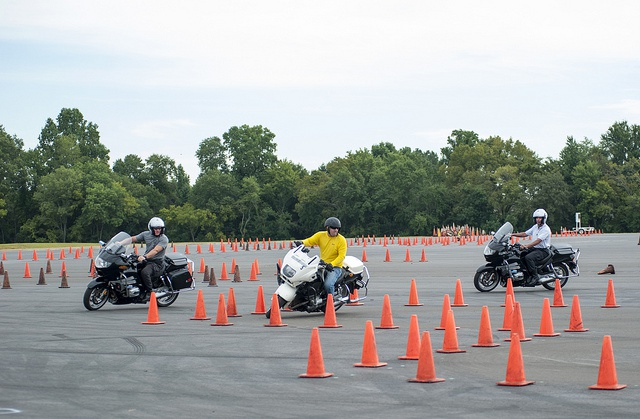Describe the objects in this image and their specific colors. I can see motorcycle in white, black, gray, darkgray, and lightgray tones, motorcycle in white, black, lightgray, darkgray, and gray tones, motorcycle in white, black, gray, and darkgray tones, people in white, gold, gray, and olive tones, and people in white, black, gray, darkgray, and lightgray tones in this image. 